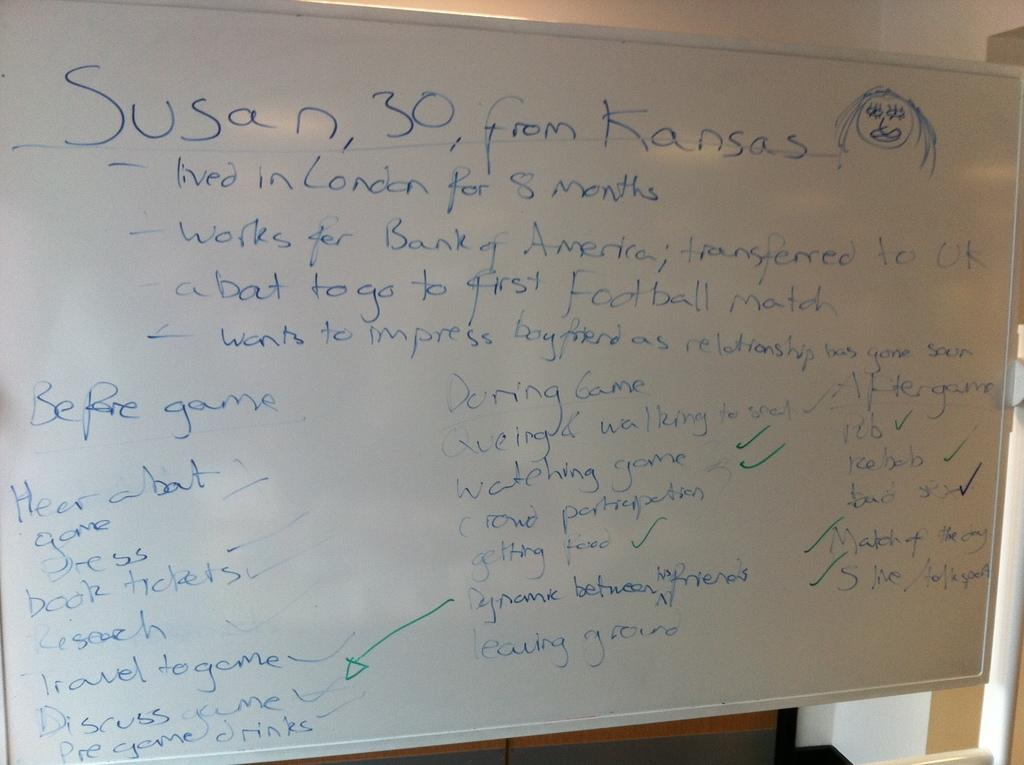What is the main object in the image? There is a board in the image. What can be found on the board? The board contains written text. What type of lettuce is being used to create the text on the board? There is no lettuce present in the image, and the text is not created using lettuce. 